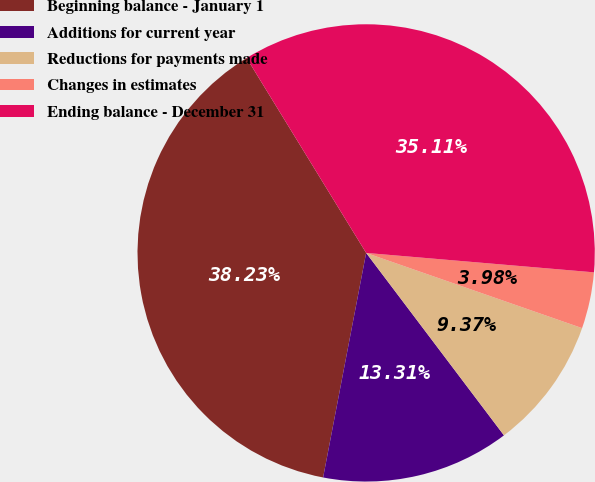<chart> <loc_0><loc_0><loc_500><loc_500><pie_chart><fcel>Beginning balance - January 1<fcel>Additions for current year<fcel>Reductions for payments made<fcel>Changes in estimates<fcel>Ending balance - December 31<nl><fcel>38.23%<fcel>13.31%<fcel>9.37%<fcel>3.98%<fcel>35.11%<nl></chart> 